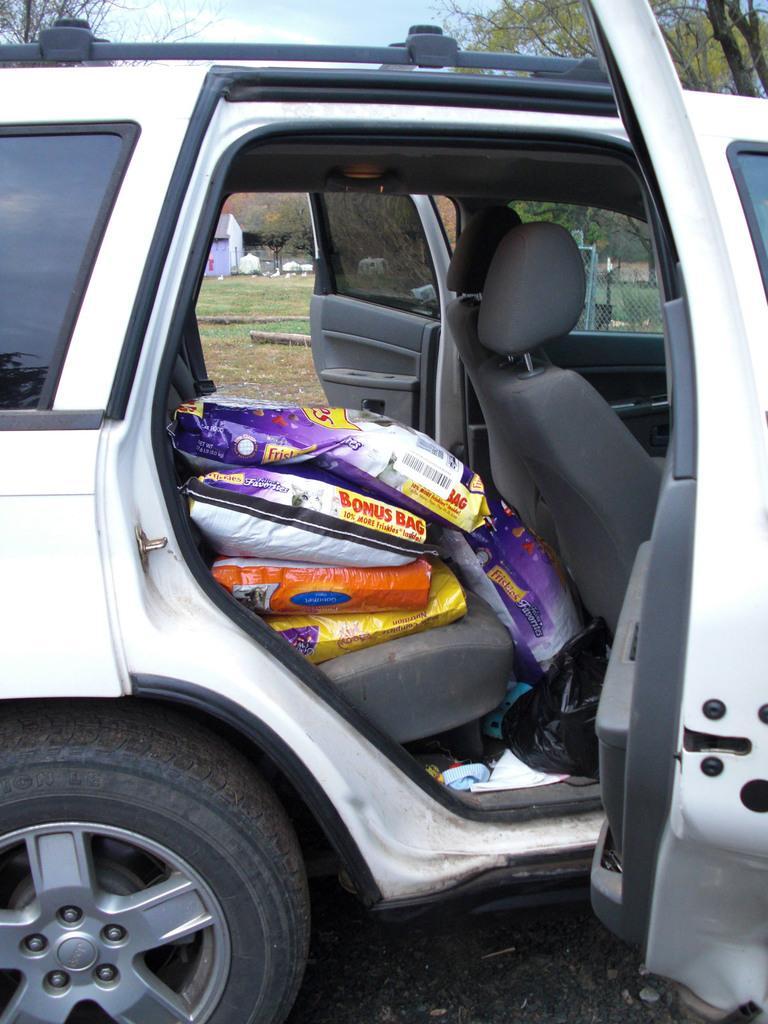Describe this image in one or two sentences. We can see bags and cover in a car. In the background we can see grass,house,fence,trees and sky. 